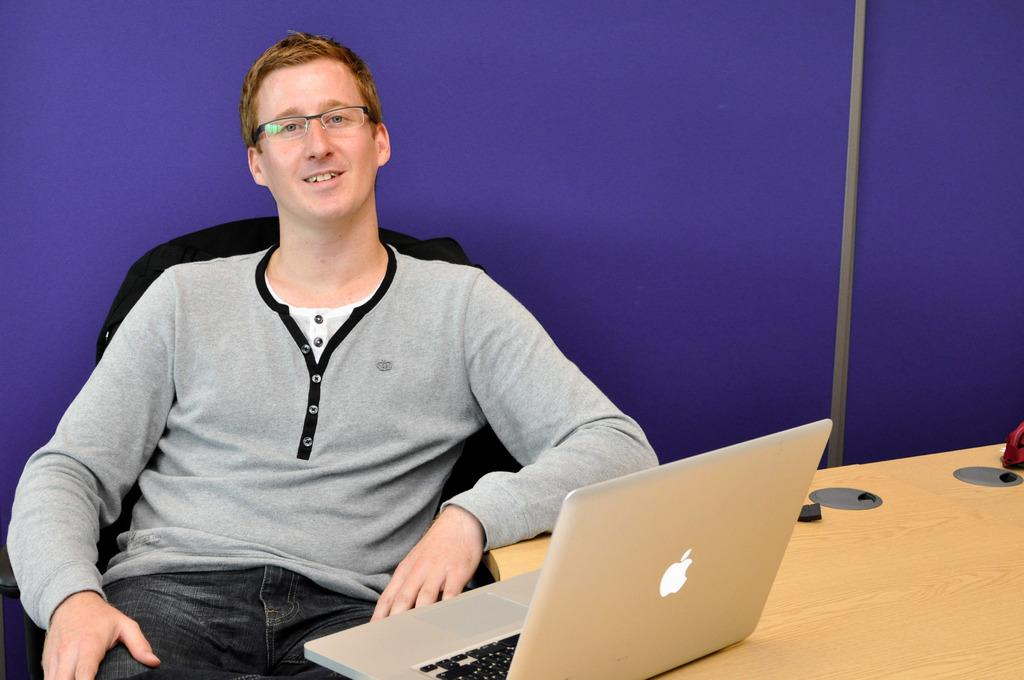What is the man doing in the image? The man is sitting on a chair on the left side of the image. What can be seen on the right side of the image? There is a table on the right side of the image. What is placed on the table? A laptop is placed on the table. What is visible in the background of the image? There is a wall in the background of the image. What type of cup can be seen in the image? There is no cup present in the image. What is the noise level in the image? The noise level cannot be determined from the image, as there is no information about sound or volume. 